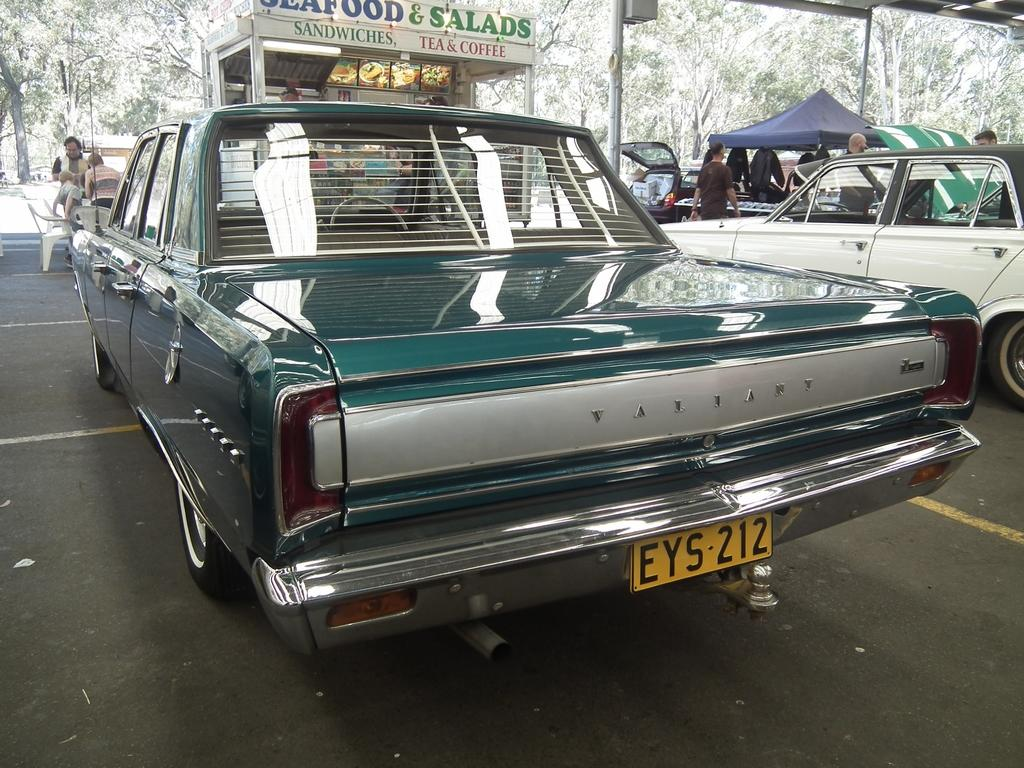What types of objects are in the image? There are vehicles, chairs, and a tent in the image. Who or what can be seen in the image? There are people and a shop in the image. What type of vegetation is visible in the image? There are trees in the image. What type of pancake is being served at the shop in the image? There is no pancake present in the image, and therefore no such activity can be observed at the shop. What role does the secretary play in the image? There is no secretary present in the image. 